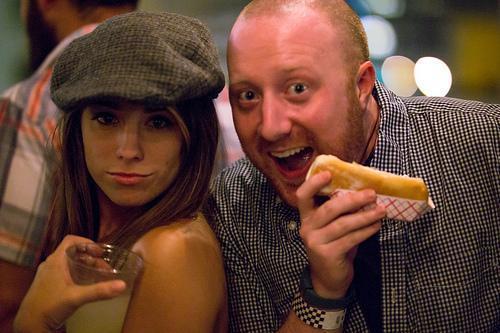How many people holding the hot dog?
Give a very brief answer. 1. 